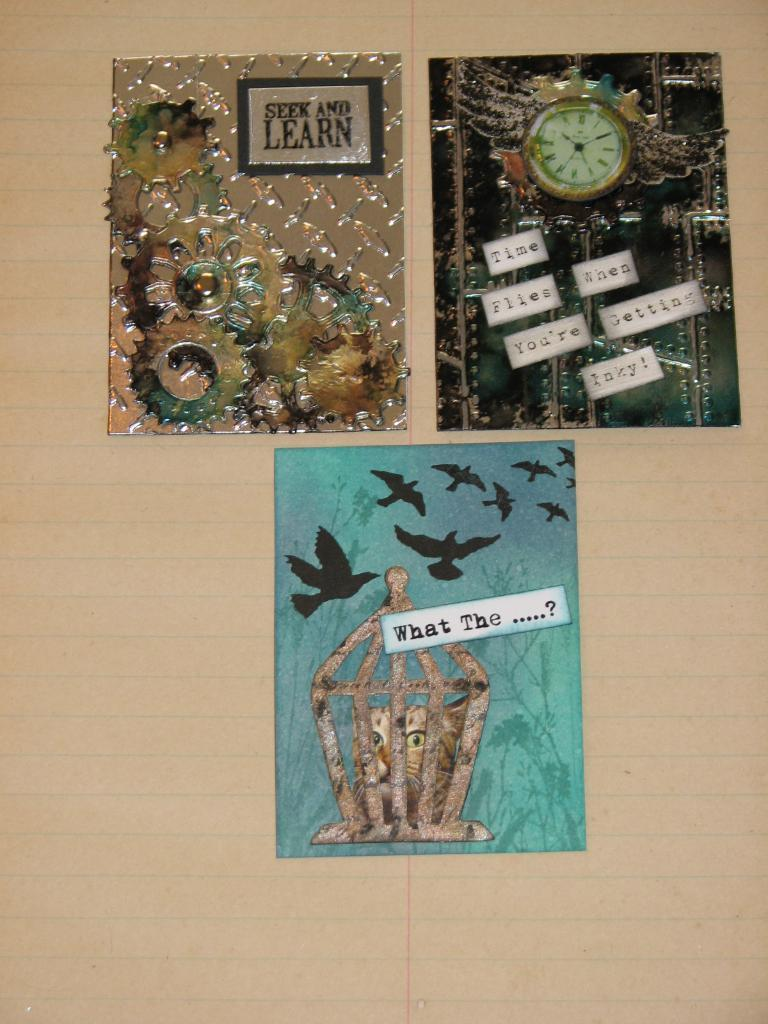Provide a one-sentence caption for the provided image. a sign that says seek and learn on it. 